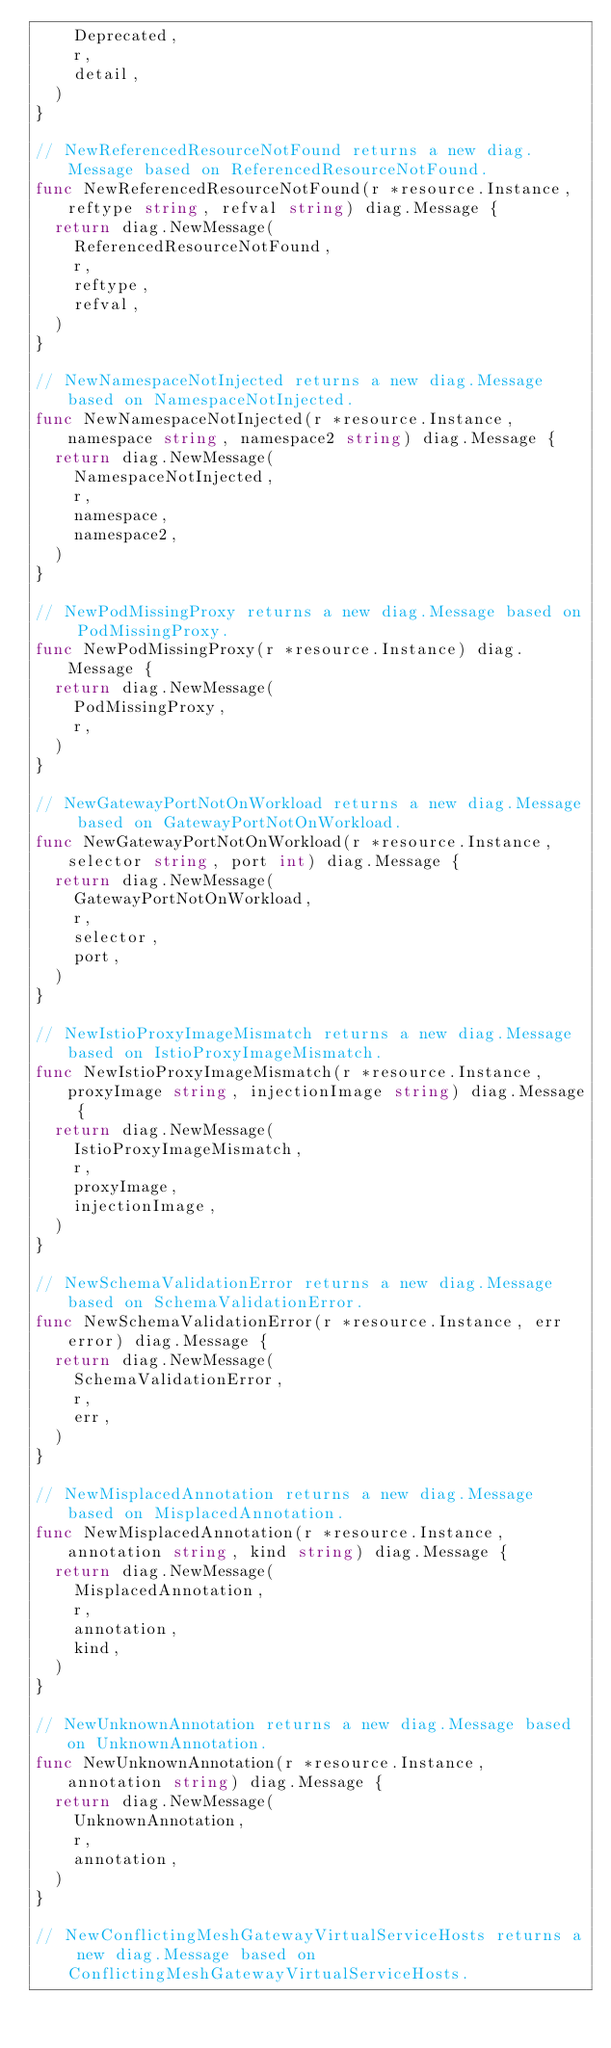<code> <loc_0><loc_0><loc_500><loc_500><_Go_>		Deprecated,
		r,
		detail,
	)
}

// NewReferencedResourceNotFound returns a new diag.Message based on ReferencedResourceNotFound.
func NewReferencedResourceNotFound(r *resource.Instance, reftype string, refval string) diag.Message {
	return diag.NewMessage(
		ReferencedResourceNotFound,
		r,
		reftype,
		refval,
	)
}

// NewNamespaceNotInjected returns a new diag.Message based on NamespaceNotInjected.
func NewNamespaceNotInjected(r *resource.Instance, namespace string, namespace2 string) diag.Message {
	return diag.NewMessage(
		NamespaceNotInjected,
		r,
		namespace,
		namespace2,
	)
}

// NewPodMissingProxy returns a new diag.Message based on PodMissingProxy.
func NewPodMissingProxy(r *resource.Instance) diag.Message {
	return diag.NewMessage(
		PodMissingProxy,
		r,
	)
}

// NewGatewayPortNotOnWorkload returns a new diag.Message based on GatewayPortNotOnWorkload.
func NewGatewayPortNotOnWorkload(r *resource.Instance, selector string, port int) diag.Message {
	return diag.NewMessage(
		GatewayPortNotOnWorkload,
		r,
		selector,
		port,
	)
}

// NewIstioProxyImageMismatch returns a new diag.Message based on IstioProxyImageMismatch.
func NewIstioProxyImageMismatch(r *resource.Instance, proxyImage string, injectionImage string) diag.Message {
	return diag.NewMessage(
		IstioProxyImageMismatch,
		r,
		proxyImage,
		injectionImage,
	)
}

// NewSchemaValidationError returns a new diag.Message based on SchemaValidationError.
func NewSchemaValidationError(r *resource.Instance, err error) diag.Message {
	return diag.NewMessage(
		SchemaValidationError,
		r,
		err,
	)
}

// NewMisplacedAnnotation returns a new diag.Message based on MisplacedAnnotation.
func NewMisplacedAnnotation(r *resource.Instance, annotation string, kind string) diag.Message {
	return diag.NewMessage(
		MisplacedAnnotation,
		r,
		annotation,
		kind,
	)
}

// NewUnknownAnnotation returns a new diag.Message based on UnknownAnnotation.
func NewUnknownAnnotation(r *resource.Instance, annotation string) diag.Message {
	return diag.NewMessage(
		UnknownAnnotation,
		r,
		annotation,
	)
}

// NewConflictingMeshGatewayVirtualServiceHosts returns a new diag.Message based on ConflictingMeshGatewayVirtualServiceHosts.</code> 